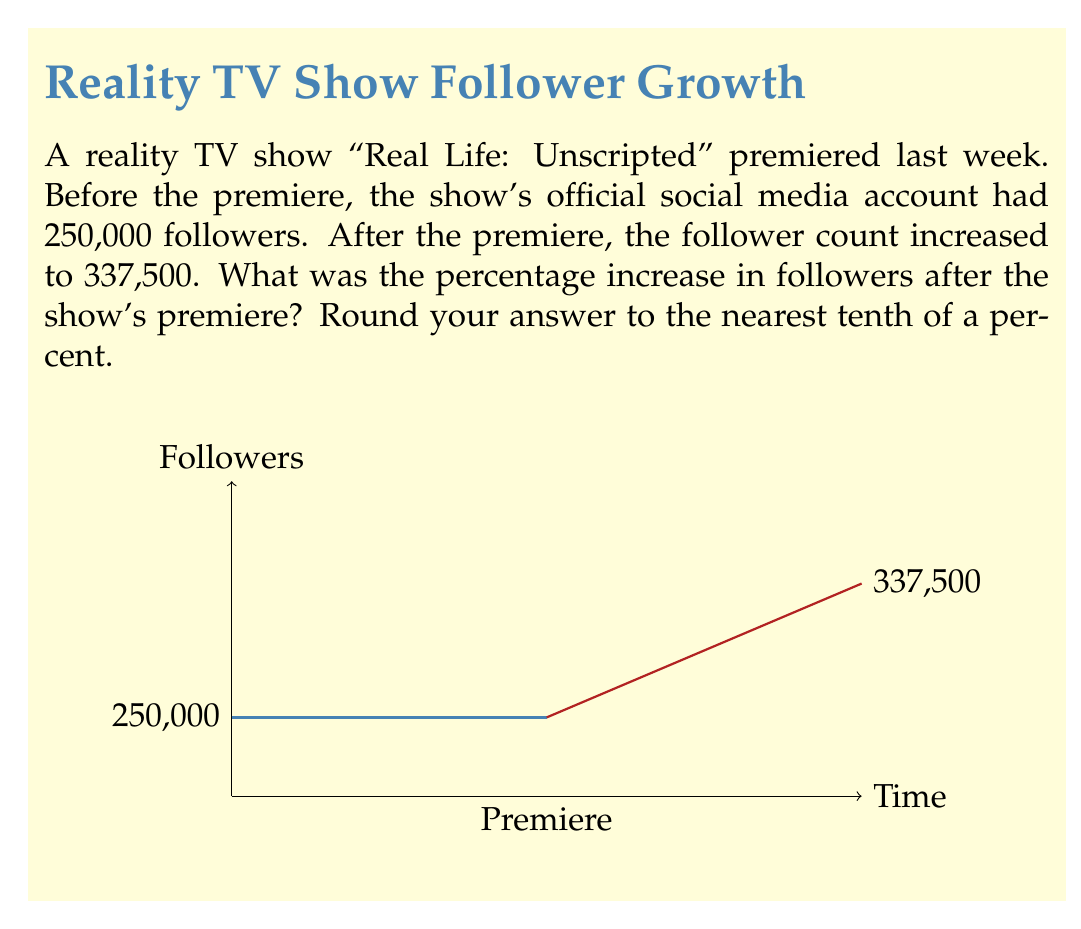What is the answer to this math problem? To calculate the percentage increase, we'll follow these steps:

1) First, let's calculate the increase in followers:
   $\text{Increase} = \text{New followers} - \text{Original followers}$
   $\text{Increase} = 337,500 - 250,000 = 87,500$

2) Now, we'll use the formula for percentage increase:
   $\text{Percentage increase} = \frac{\text{Increase}}{\text{Original value}} \times 100\%$

3) Plugging in our values:
   $\text{Percentage increase} = \frac{87,500}{250,000} \times 100\%$

4) Simplify the fraction:
   $\text{Percentage increase} = 0.35 \times 100\%$

5) Calculate:
   $\text{Percentage increase} = 35\%$

6) The question asks to round to the nearest tenth of a percent, but 35% is already in that form.

Therefore, the percentage increase in followers after the show's premiere was 35.0%.
Answer: 35.0% 